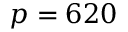Convert formula to latex. <formula><loc_0><loc_0><loc_500><loc_500>p = 6 2 0</formula> 